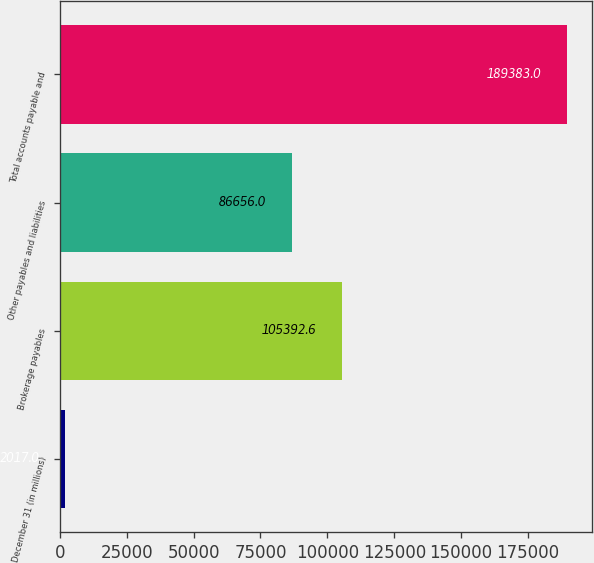Convert chart to OTSL. <chart><loc_0><loc_0><loc_500><loc_500><bar_chart><fcel>December 31 (in millions)<fcel>Brokerage payables<fcel>Other payables and liabilities<fcel>Total accounts payable and<nl><fcel>2017<fcel>105393<fcel>86656<fcel>189383<nl></chart> 